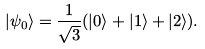<formula> <loc_0><loc_0><loc_500><loc_500>| \psi _ { 0 } \rangle = \frac { 1 } { \sqrt { 3 } } ( | 0 \rangle + | 1 \rangle + | 2 \rangle ) .</formula> 